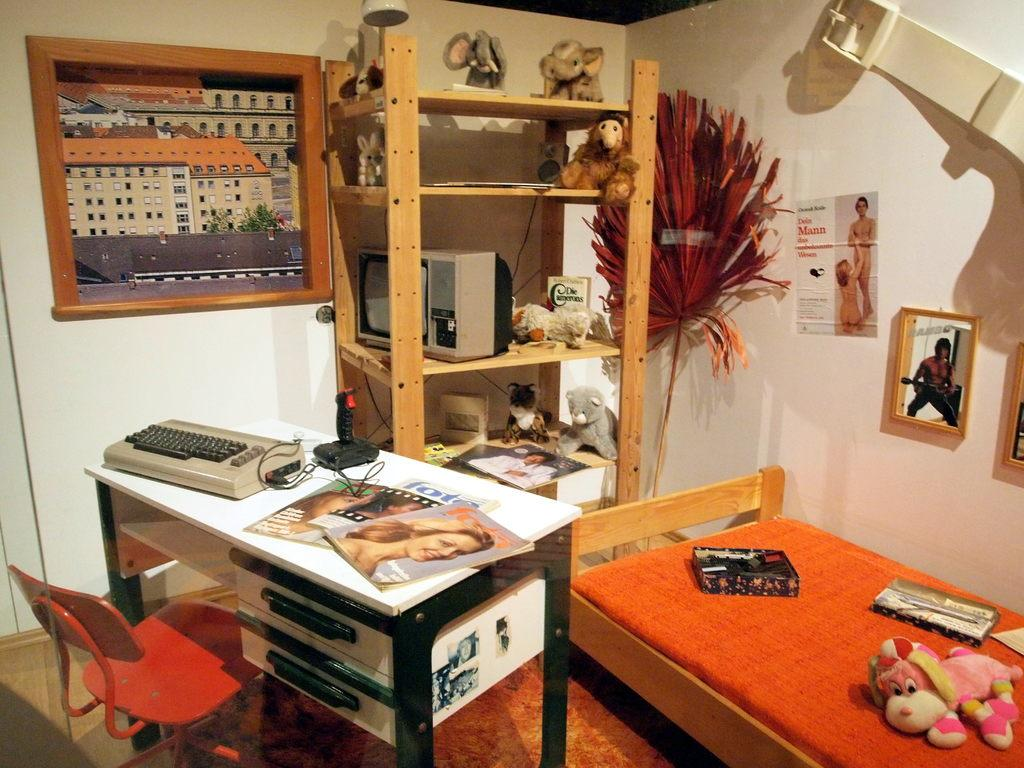What piece of furniture is located on the right side of the image? There is a bed on the right side of the image. What is on top of the bed in the image? There are toys on the bed. What is on the left side of the image? There is a table on the left side of the image. What is next to the table in the image? There is a chair next to the table. What can be seen in the middle of the image on the wall? There is a frame on the wall in the middle of the image. How many children are participating in the event depicted in the image? There is no event or children present in the image; it features a bed, table, chair, toys, and a frame on the wall. 